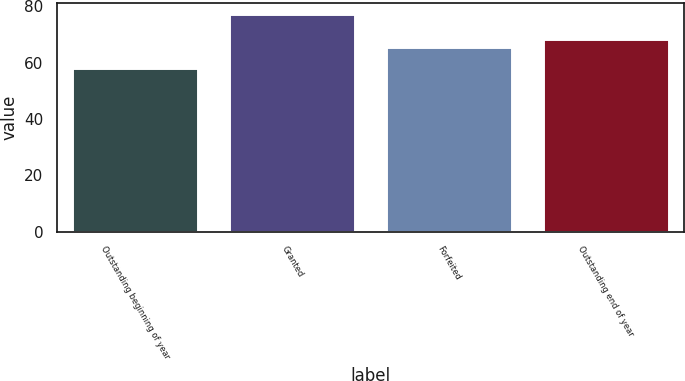Convert chart to OTSL. <chart><loc_0><loc_0><loc_500><loc_500><bar_chart><fcel>Outstanding beginning of year<fcel>Granted<fcel>Forfeited<fcel>Outstanding end of year<nl><fcel>58.22<fcel>77.29<fcel>65.6<fcel>68.29<nl></chart> 